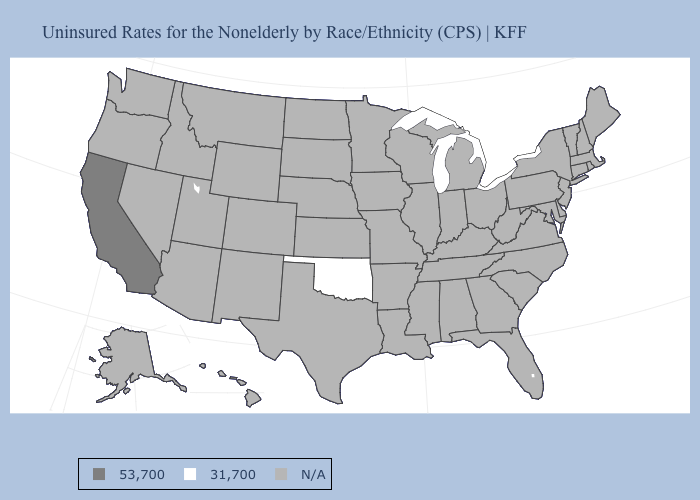What is the value of Maine?
Quick response, please. N/A. Name the states that have a value in the range 31,700?
Answer briefly. Oklahoma. Name the states that have a value in the range 53,700?
Give a very brief answer. California. What is the lowest value in states that border Texas?
Give a very brief answer. 31,700. What is the lowest value in states that border Arizona?
Quick response, please. 53,700. Does California have the lowest value in the USA?
Be succinct. No. Name the states that have a value in the range N/A?
Write a very short answer. Alabama, Alaska, Arizona, Arkansas, Colorado, Connecticut, Delaware, Florida, Georgia, Hawaii, Idaho, Illinois, Indiana, Iowa, Kansas, Kentucky, Louisiana, Maine, Maryland, Massachusetts, Michigan, Minnesota, Mississippi, Missouri, Montana, Nebraska, Nevada, New Hampshire, New Jersey, New Mexico, New York, North Carolina, North Dakota, Ohio, Oregon, Pennsylvania, Rhode Island, South Carolina, South Dakota, Tennessee, Texas, Utah, Vermont, Virginia, Washington, West Virginia, Wisconsin, Wyoming. Does the first symbol in the legend represent the smallest category?
Short answer required. No. Name the states that have a value in the range 53,700?
Quick response, please. California. Does the map have missing data?
Answer briefly. Yes. Name the states that have a value in the range N/A?
Write a very short answer. Alabama, Alaska, Arizona, Arkansas, Colorado, Connecticut, Delaware, Florida, Georgia, Hawaii, Idaho, Illinois, Indiana, Iowa, Kansas, Kentucky, Louisiana, Maine, Maryland, Massachusetts, Michigan, Minnesota, Mississippi, Missouri, Montana, Nebraska, Nevada, New Hampshire, New Jersey, New Mexico, New York, North Carolina, North Dakota, Ohio, Oregon, Pennsylvania, Rhode Island, South Carolina, South Dakota, Tennessee, Texas, Utah, Vermont, Virginia, Washington, West Virginia, Wisconsin, Wyoming. 